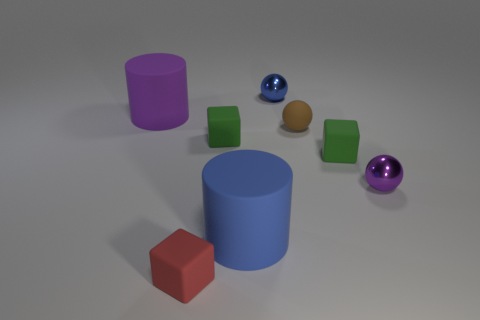Add 1 tiny red rubber objects. How many objects exist? 9 Subtract all blocks. How many objects are left? 5 Subtract all small purple shiny cubes. Subtract all shiny things. How many objects are left? 6 Add 8 blue matte things. How many blue matte things are left? 9 Add 3 large objects. How many large objects exist? 5 Subtract 1 brown balls. How many objects are left? 7 